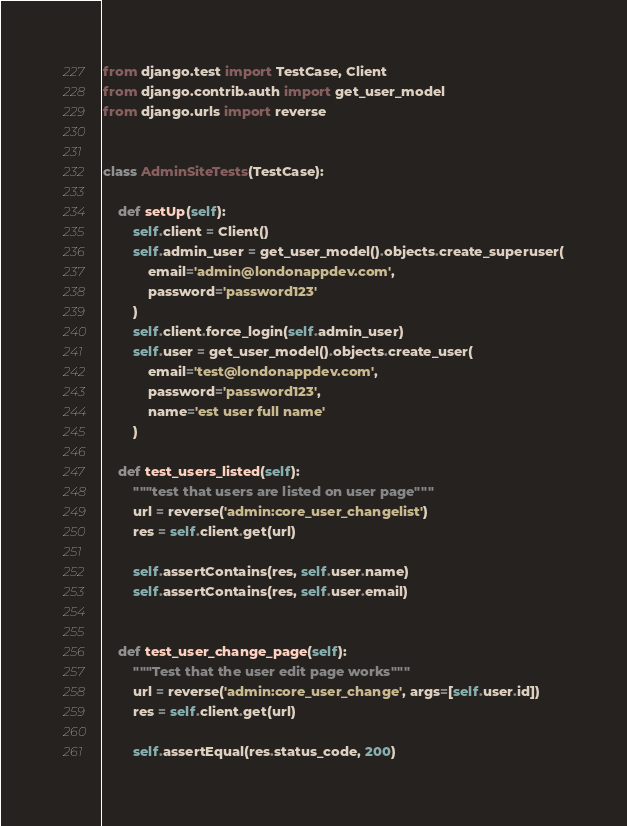<code> <loc_0><loc_0><loc_500><loc_500><_Python_>from django.test import TestCase, Client
from django.contrib.auth import get_user_model
from django.urls import reverse


class AdminSiteTests(TestCase):

    def setUp(self):
        self.client = Client()
        self.admin_user = get_user_model().objects.create_superuser(
            email='admin@londonappdev.com',
            password='password123'
        )
        self.client.force_login(self.admin_user)
        self.user = get_user_model().objects.create_user(
            email='test@londonappdev.com',
            password='password123',
            name='est user full name'
        )

    def test_users_listed(self):
        """test that users are listed on user page"""
        url = reverse('admin:core_user_changelist')
        res = self.client.get(url)

        self.assertContains(res, self.user.name)
        self.assertContains(res, self.user.email)


    def test_user_change_page(self):
        """Test that the user edit page works"""
        url = reverse('admin:core_user_change', args=[self.user.id])
        res = self.client.get(url)

        self.assertEqual(res.status_code, 200)
</code> 